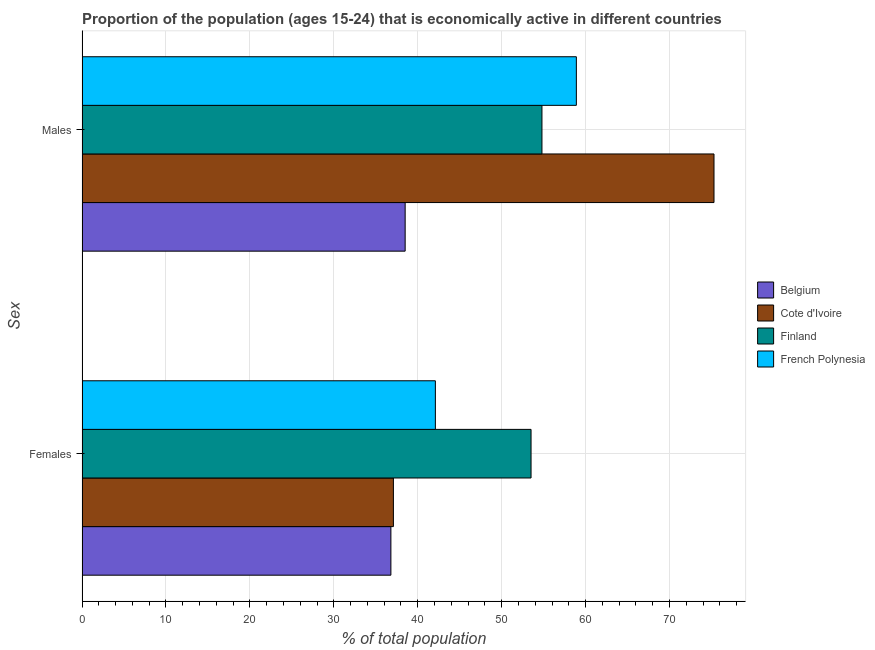How many groups of bars are there?
Provide a succinct answer. 2. How many bars are there on the 1st tick from the top?
Provide a short and direct response. 4. What is the label of the 1st group of bars from the top?
Your answer should be very brief. Males. What is the percentage of economically active female population in French Polynesia?
Offer a terse response. 42.1. Across all countries, what is the maximum percentage of economically active male population?
Give a very brief answer. 75.3. Across all countries, what is the minimum percentage of economically active female population?
Offer a very short reply. 36.8. In which country was the percentage of economically active male population maximum?
Your answer should be compact. Cote d'Ivoire. What is the total percentage of economically active female population in the graph?
Make the answer very short. 169.5. What is the difference between the percentage of economically active male population in French Polynesia and that in Cote d'Ivoire?
Make the answer very short. -16.4. What is the difference between the percentage of economically active female population in Finland and the percentage of economically active male population in Cote d'Ivoire?
Provide a succinct answer. -21.8. What is the average percentage of economically active male population per country?
Your answer should be compact. 56.88. What is the difference between the percentage of economically active female population and percentage of economically active male population in French Polynesia?
Provide a succinct answer. -16.8. In how many countries, is the percentage of economically active male population greater than 40 %?
Your answer should be very brief. 3. What is the ratio of the percentage of economically active male population in Cote d'Ivoire to that in French Polynesia?
Your answer should be very brief. 1.28. Is the percentage of economically active female population in Belgium less than that in Cote d'Ivoire?
Provide a succinct answer. Yes. In how many countries, is the percentage of economically active female population greater than the average percentage of economically active female population taken over all countries?
Provide a short and direct response. 1. What does the 4th bar from the bottom in Males represents?
Offer a very short reply. French Polynesia. How many countries are there in the graph?
Give a very brief answer. 4. What is the difference between two consecutive major ticks on the X-axis?
Your answer should be very brief. 10. Does the graph contain any zero values?
Provide a succinct answer. No. Does the graph contain grids?
Offer a very short reply. Yes. Where does the legend appear in the graph?
Your answer should be very brief. Center right. How many legend labels are there?
Provide a short and direct response. 4. How are the legend labels stacked?
Your answer should be compact. Vertical. What is the title of the graph?
Offer a terse response. Proportion of the population (ages 15-24) that is economically active in different countries. What is the label or title of the X-axis?
Give a very brief answer. % of total population. What is the label or title of the Y-axis?
Offer a terse response. Sex. What is the % of total population of Belgium in Females?
Your answer should be very brief. 36.8. What is the % of total population of Cote d'Ivoire in Females?
Keep it short and to the point. 37.1. What is the % of total population of Finland in Females?
Make the answer very short. 53.5. What is the % of total population of French Polynesia in Females?
Your answer should be compact. 42.1. What is the % of total population in Belgium in Males?
Offer a terse response. 38.5. What is the % of total population of Cote d'Ivoire in Males?
Your response must be concise. 75.3. What is the % of total population of Finland in Males?
Provide a short and direct response. 54.8. What is the % of total population in French Polynesia in Males?
Your response must be concise. 58.9. Across all Sex, what is the maximum % of total population of Belgium?
Your response must be concise. 38.5. Across all Sex, what is the maximum % of total population in Cote d'Ivoire?
Make the answer very short. 75.3. Across all Sex, what is the maximum % of total population of Finland?
Offer a very short reply. 54.8. Across all Sex, what is the maximum % of total population in French Polynesia?
Offer a very short reply. 58.9. Across all Sex, what is the minimum % of total population in Belgium?
Give a very brief answer. 36.8. Across all Sex, what is the minimum % of total population of Cote d'Ivoire?
Keep it short and to the point. 37.1. Across all Sex, what is the minimum % of total population in Finland?
Make the answer very short. 53.5. Across all Sex, what is the minimum % of total population of French Polynesia?
Keep it short and to the point. 42.1. What is the total % of total population of Belgium in the graph?
Offer a very short reply. 75.3. What is the total % of total population of Cote d'Ivoire in the graph?
Offer a very short reply. 112.4. What is the total % of total population in Finland in the graph?
Keep it short and to the point. 108.3. What is the total % of total population of French Polynesia in the graph?
Make the answer very short. 101. What is the difference between the % of total population of Cote d'Ivoire in Females and that in Males?
Offer a terse response. -38.2. What is the difference between the % of total population in French Polynesia in Females and that in Males?
Offer a very short reply. -16.8. What is the difference between the % of total population of Belgium in Females and the % of total population of Cote d'Ivoire in Males?
Ensure brevity in your answer.  -38.5. What is the difference between the % of total population in Belgium in Females and the % of total population in French Polynesia in Males?
Provide a short and direct response. -22.1. What is the difference between the % of total population of Cote d'Ivoire in Females and the % of total population of Finland in Males?
Ensure brevity in your answer.  -17.7. What is the difference between the % of total population in Cote d'Ivoire in Females and the % of total population in French Polynesia in Males?
Provide a succinct answer. -21.8. What is the average % of total population of Belgium per Sex?
Provide a succinct answer. 37.65. What is the average % of total population in Cote d'Ivoire per Sex?
Provide a succinct answer. 56.2. What is the average % of total population of Finland per Sex?
Make the answer very short. 54.15. What is the average % of total population of French Polynesia per Sex?
Give a very brief answer. 50.5. What is the difference between the % of total population of Belgium and % of total population of Cote d'Ivoire in Females?
Provide a short and direct response. -0.3. What is the difference between the % of total population of Belgium and % of total population of Finland in Females?
Your answer should be compact. -16.7. What is the difference between the % of total population of Cote d'Ivoire and % of total population of Finland in Females?
Your response must be concise. -16.4. What is the difference between the % of total population in Finland and % of total population in French Polynesia in Females?
Your answer should be compact. 11.4. What is the difference between the % of total population in Belgium and % of total population in Cote d'Ivoire in Males?
Offer a terse response. -36.8. What is the difference between the % of total population in Belgium and % of total population in Finland in Males?
Provide a succinct answer. -16.3. What is the difference between the % of total population in Belgium and % of total population in French Polynesia in Males?
Give a very brief answer. -20.4. What is the difference between the % of total population in Finland and % of total population in French Polynesia in Males?
Your answer should be compact. -4.1. What is the ratio of the % of total population of Belgium in Females to that in Males?
Keep it short and to the point. 0.96. What is the ratio of the % of total population of Cote d'Ivoire in Females to that in Males?
Offer a terse response. 0.49. What is the ratio of the % of total population of Finland in Females to that in Males?
Keep it short and to the point. 0.98. What is the ratio of the % of total population of French Polynesia in Females to that in Males?
Give a very brief answer. 0.71. What is the difference between the highest and the second highest % of total population in Cote d'Ivoire?
Your response must be concise. 38.2. What is the difference between the highest and the second highest % of total population in Finland?
Your answer should be very brief. 1.3. What is the difference between the highest and the second highest % of total population of French Polynesia?
Keep it short and to the point. 16.8. What is the difference between the highest and the lowest % of total population in Cote d'Ivoire?
Make the answer very short. 38.2. What is the difference between the highest and the lowest % of total population of French Polynesia?
Your response must be concise. 16.8. 